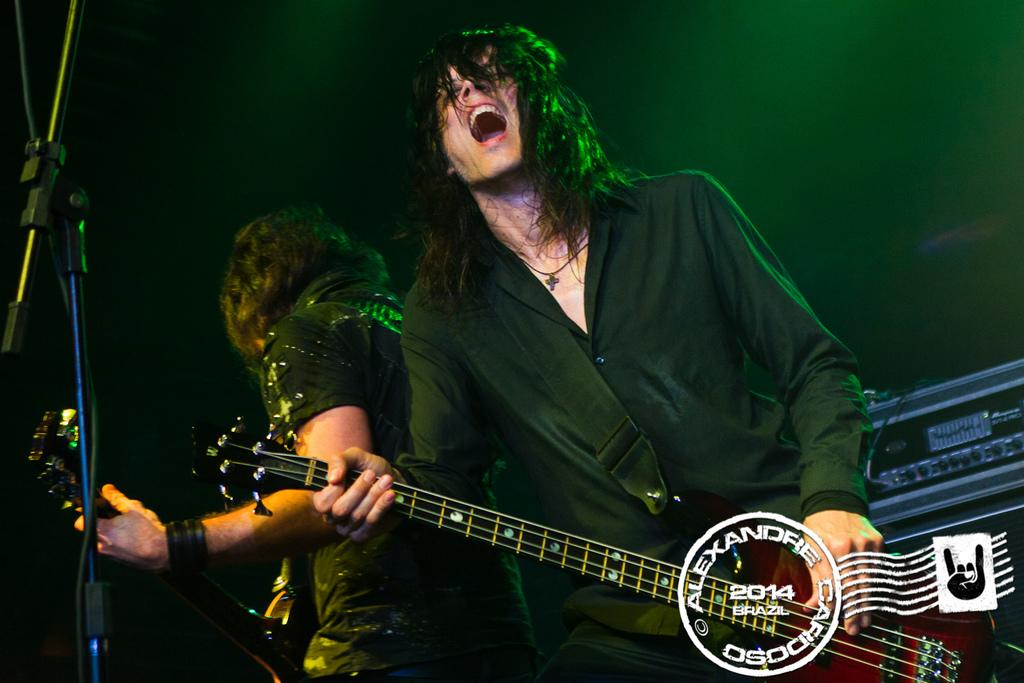What is the main subject of the image? The main subjects of the image are two men. What are the men doing in the image? Both men are playing the guitar in the image. What type of skirt is the nation wearing in the image? There is no nation or skirt present in the image; it features two men playing the guitar. 